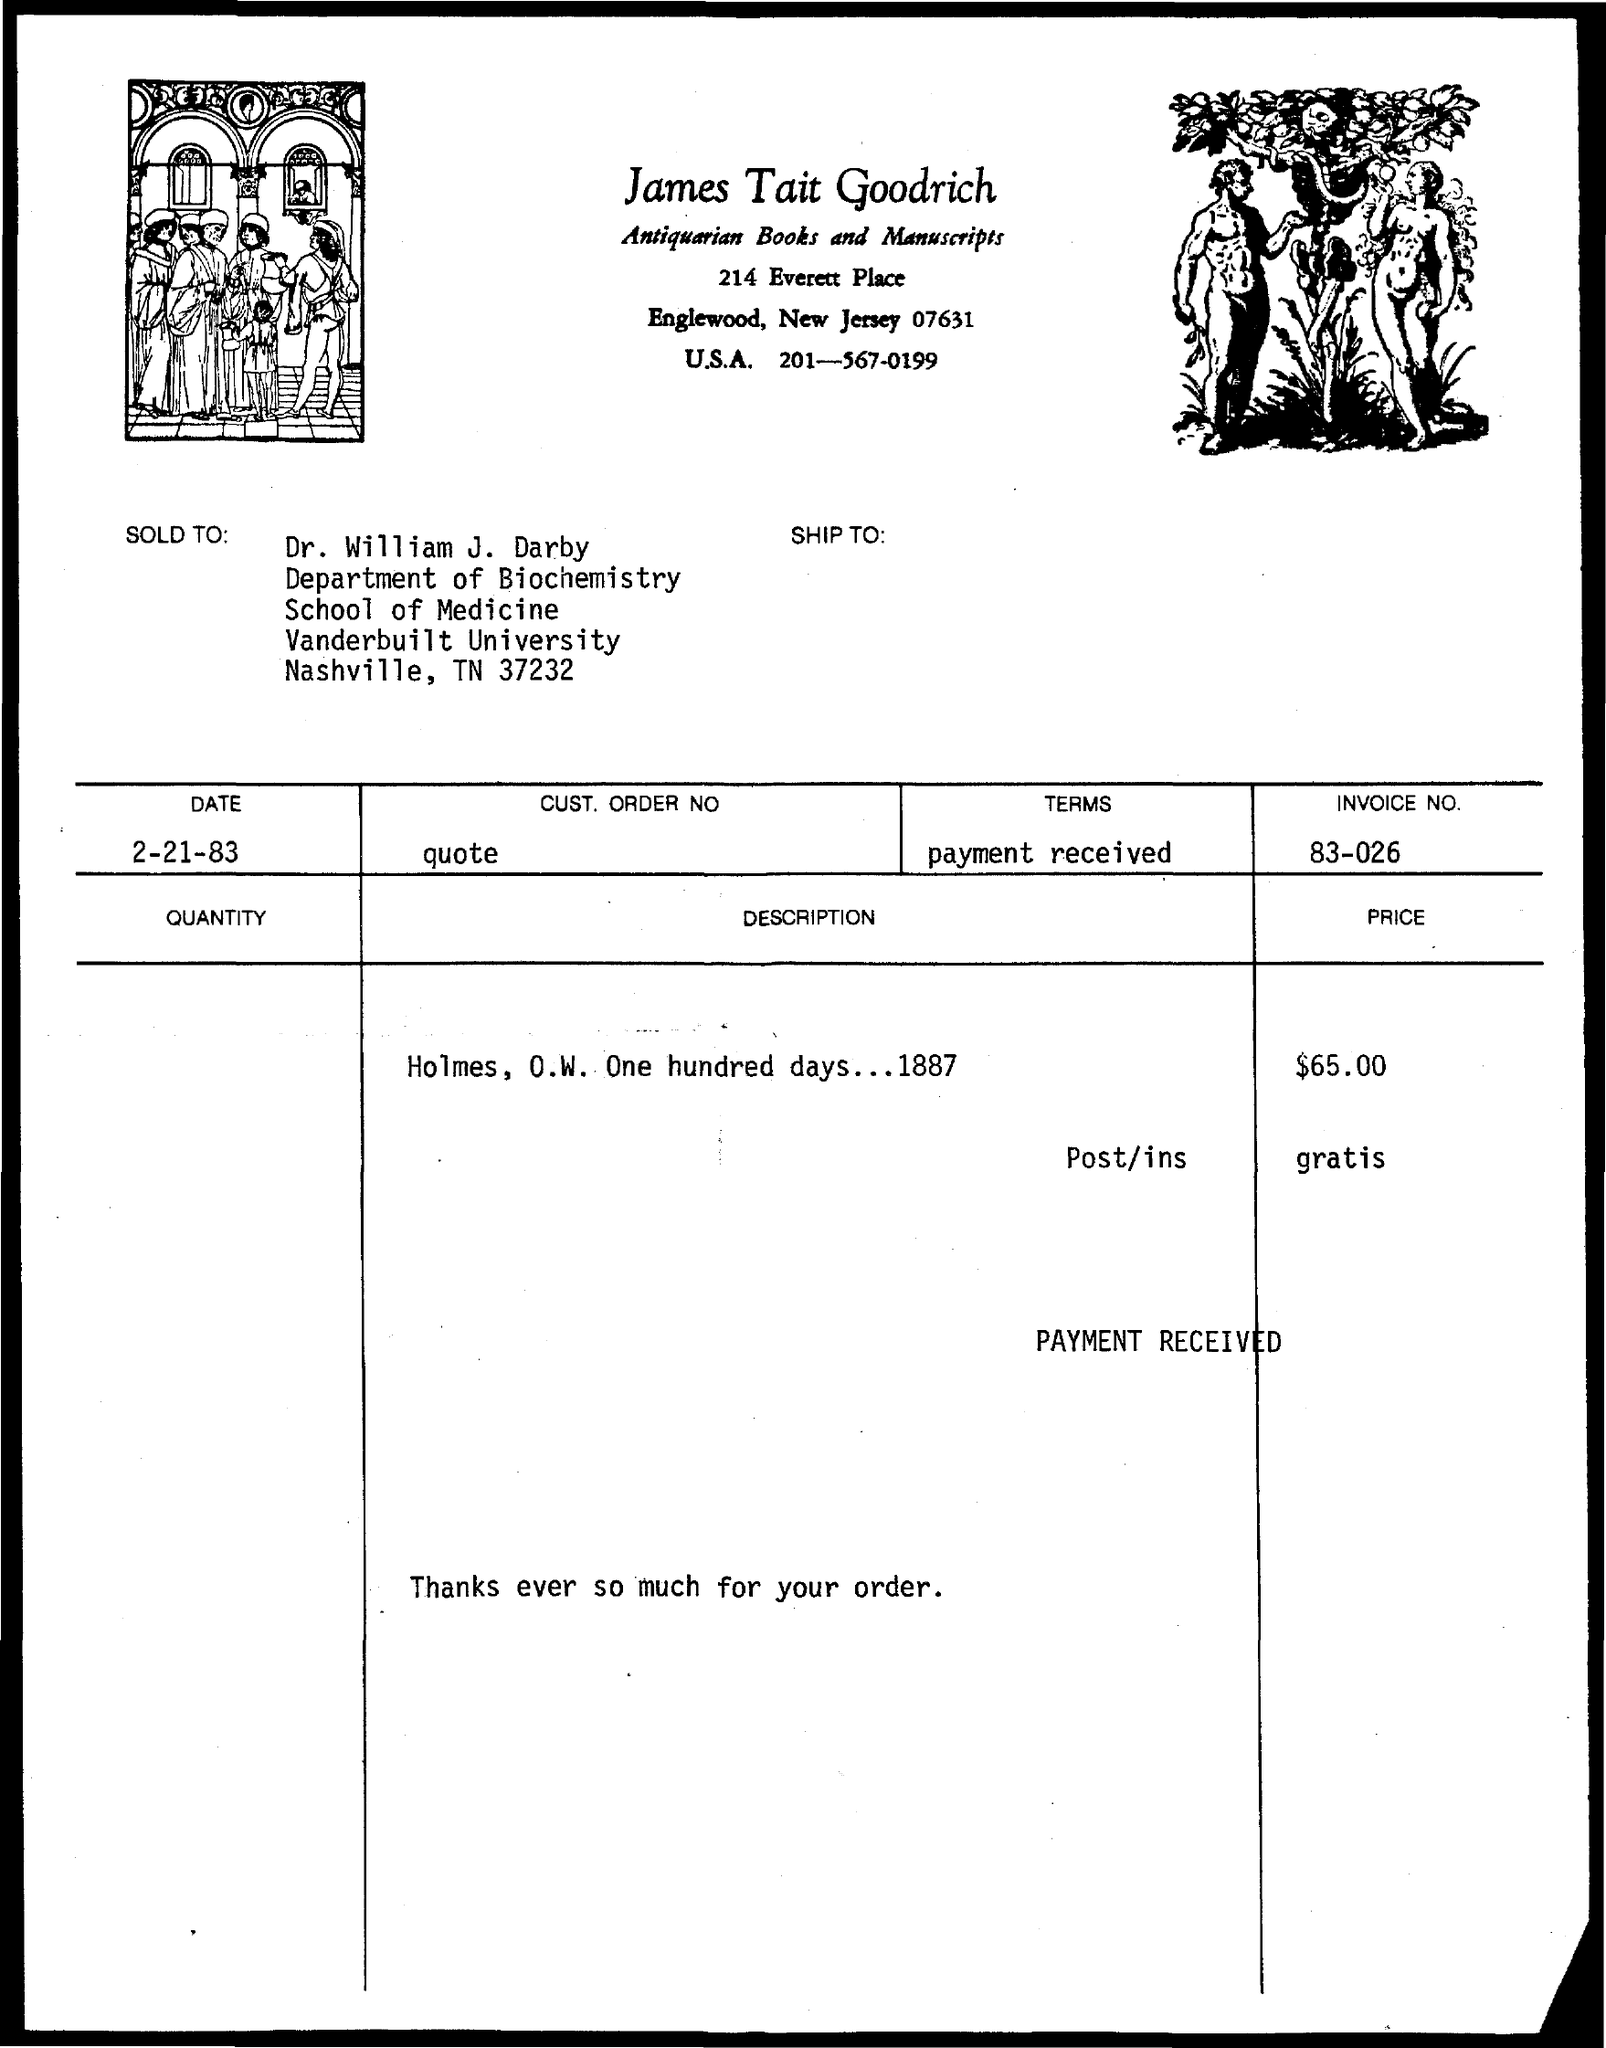What is the date mentioned in the given form ?
Provide a short and direct response. 2-21-83. What is the invoice no. mentioned in the given form ?
Give a very brief answer. 83-026. To whom it was sold to ?
Your answer should be very brief. Dr. william j. darby. To which department dr. william j. darby belongs to ?
Make the answer very short. Department of biochemistry. To which university dr. william j. darby belongs to ?
Give a very brief answer. Vanderbuilt university. 